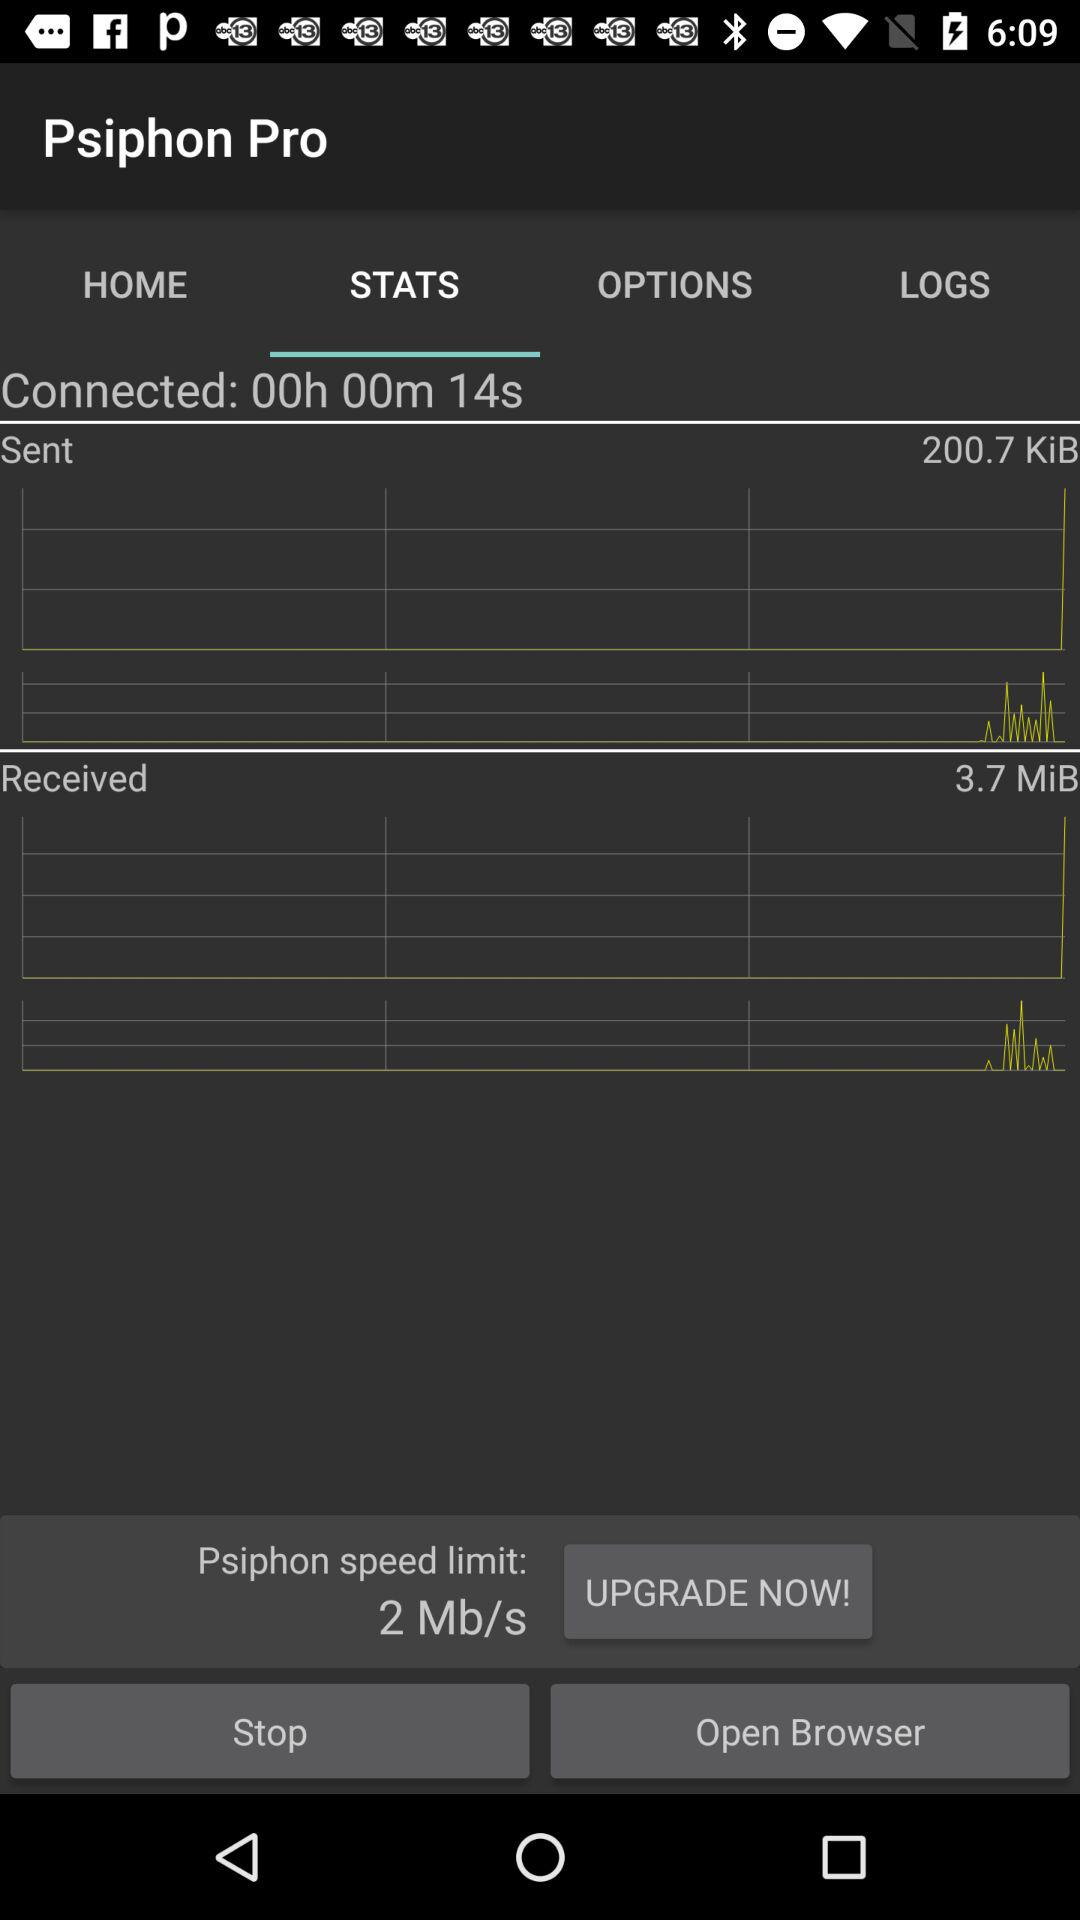For how long has the connection been established? The connection has been established for 14 seconds. 